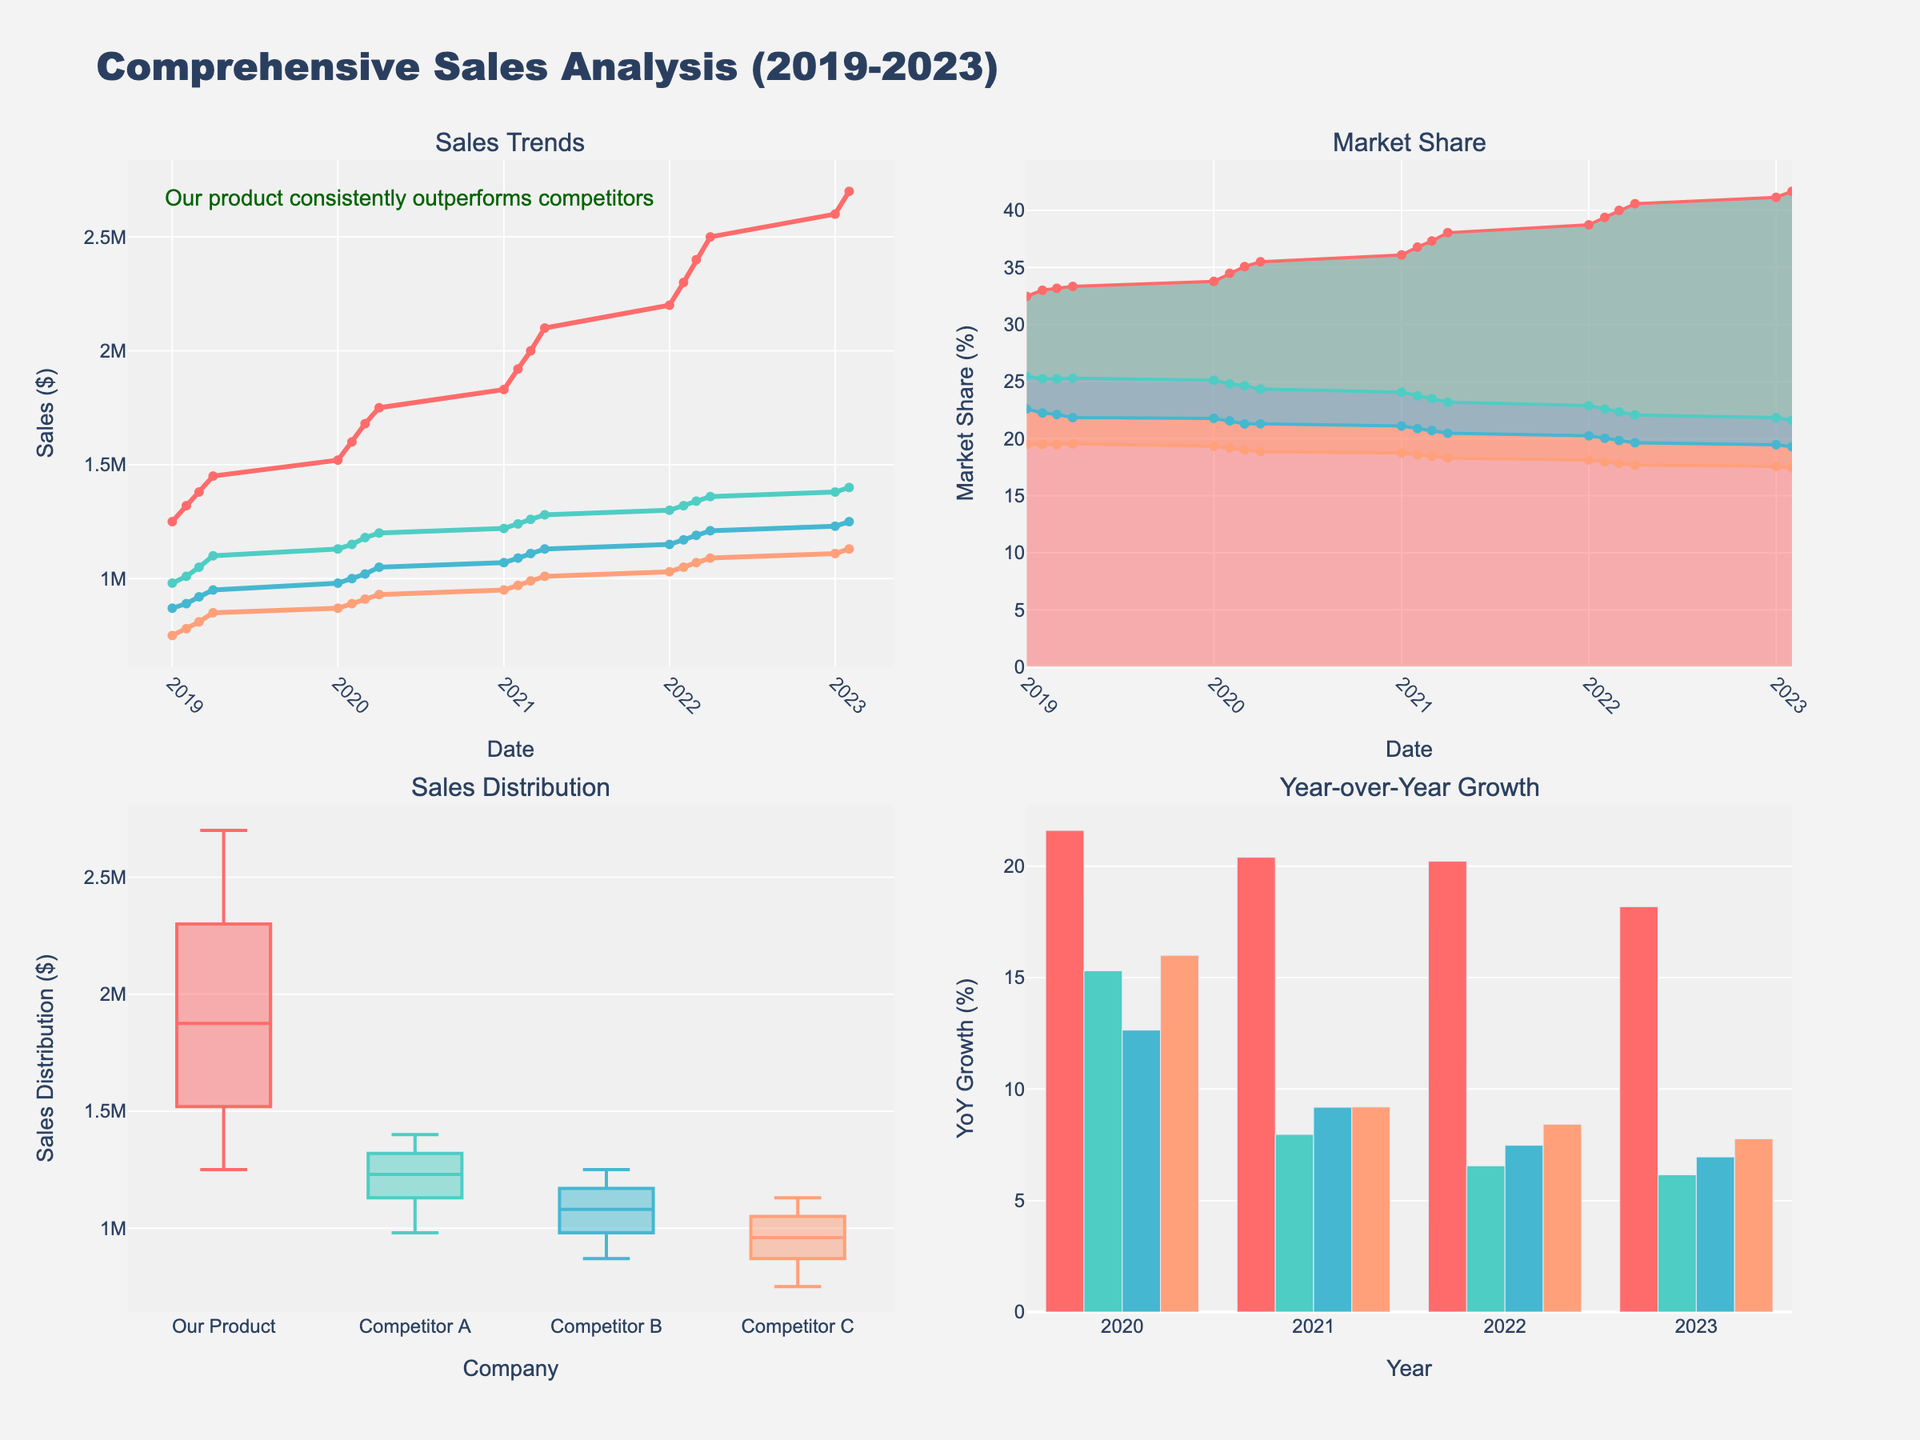What is the title of the figure? The title is usually placed at the top of the figure. It provides an overview of what the figure represents.
Answer: Comprehensive Sales Analysis (2019-2023) What is the color representing 'Our Product' in the line chart? In the line chart (top-left), 'Our Product' is represented by a specific color as indicated in the legend.
Answer: Red Which company had the highest sales in Q1 2022? By observing the line chart for sales trends (top-left), we can see the values for each company in Q1 2022 and determine which is the highest.
Answer: Our Product What was the market share of 'Competitor B' in Q3 2021? The market share is visualized in the stacked area chart (top-right). By locating Q3 2021, we can ascertain the percentage filled by 'Competitor B'.
Answer: 28.57% Which quarter shows the highest sales distribution for 'Competitor C'? Referring to the box plot (bottom-left), we can see the spread of sales data and identify which quarter has the highest distribution point.
Answer: 2023 Q1 Which year had the highest year-over-year growth rate for 'Our Product'? Looking at the bar chart for year-over-year growth (bottom-right), the height of the bars indicates the growth rate, making it clear which is the highest.
Answer: 2020 What is the median value of 'Competitor A' in the box plot? The box plot's middle line within the box represents the median value. By checking the box plot corresponding to 'Competitor A', we find the median.
Answer: Approximately 1190000 Did 'Competitor C' ever outperform 'Competitor A' in any quarter between 2019 and 2023? By comparing the lines of 'Competitor C' and 'Competitor A' in the sales trends line chart, we can see if 'Competitor C' ever surpasses 'Competitor A'.
Answer: No How does the sales trend of 'Our Product' compare to 'Competitor B' over the years? By observing the increase or decrease in sales for both 'Our Product' and 'Competitor B' in the sales trends line chart, we can analyze their trajectories.
Answer: Our Product consistently outperformed Competitor B What percentage did 'Our Product' hold in the market in the last quarter of 2022? In the stacked area chart for market share, locate the last quarter of 2022 and determine the percentage area that 'Our Product' covers.
Answer: 41.32% 